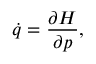<formula> <loc_0><loc_0><loc_500><loc_500>{ \dot { q } } = { \frac { \partial H } { \partial p } } ,</formula> 